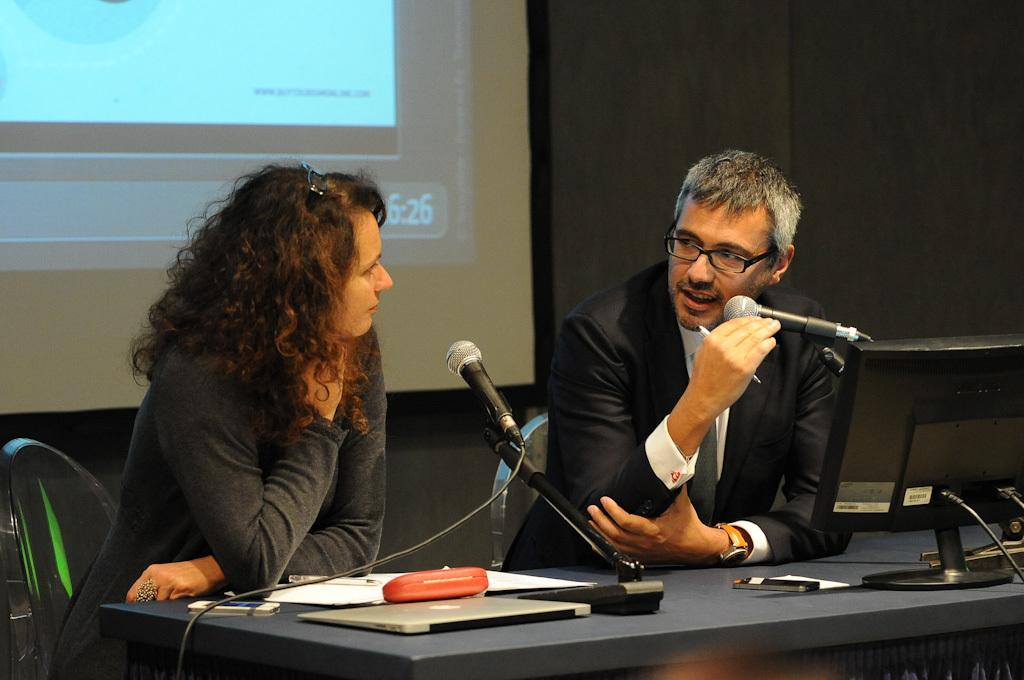What type of furniture is present in the image? There are chairs in the image. Can you describe the people in the image? There are people in the image. What is on the table in the image? There is a table with a laptop in the image. What other electronic device is visible in the image? There is a monitor in the image. What equipment might be used for recording or amplifying sound in the image? There are microphones in the image. What is on the wall in the background of the image? There is a screen on the wall in the background of the image. What color is the grape that is being eaten by the person in the image? There is no grape present in the image. What type of vehicle is parked outside the room in the image? There is no vehicle visible in the image. 